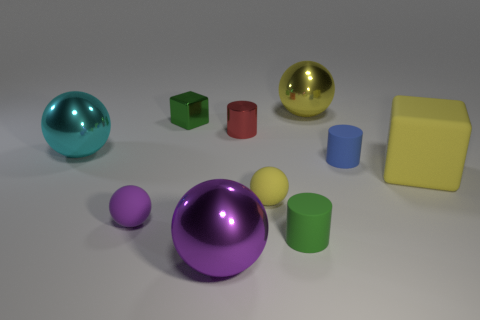Subtract all tiny yellow rubber spheres. How many spheres are left? 4 Subtract all gray blocks. How many yellow balls are left? 2 Subtract all cyan spheres. How many spheres are left? 4 Subtract all blocks. How many objects are left? 8 Subtract all small blue metallic cylinders. Subtract all cyan shiny objects. How many objects are left? 9 Add 7 tiny red cylinders. How many tiny red cylinders are left? 8 Add 2 big metallic spheres. How many big metallic spheres exist? 5 Subtract 1 purple spheres. How many objects are left? 9 Subtract all cyan balls. Subtract all gray cubes. How many balls are left? 4 